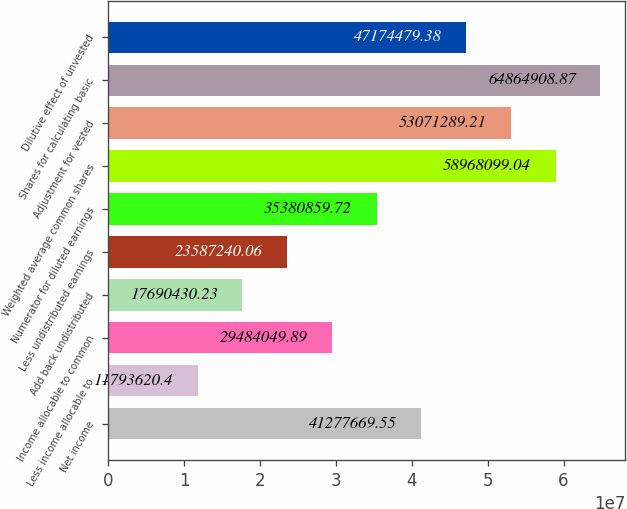Convert chart. <chart><loc_0><loc_0><loc_500><loc_500><bar_chart><fcel>Net income<fcel>Less income allocable to<fcel>Income allocable to common<fcel>Add back undistributed<fcel>Less undistributed earnings<fcel>Numerator for diluted earnings<fcel>Weighted average common shares<fcel>Adjustment for vested<fcel>Shares for calculating basic<fcel>Dilutive effect of unvested<nl><fcel>4.12777e+07<fcel>1.17936e+07<fcel>2.9484e+07<fcel>1.76904e+07<fcel>2.35872e+07<fcel>3.53809e+07<fcel>5.89681e+07<fcel>5.30713e+07<fcel>6.48649e+07<fcel>4.71745e+07<nl></chart> 